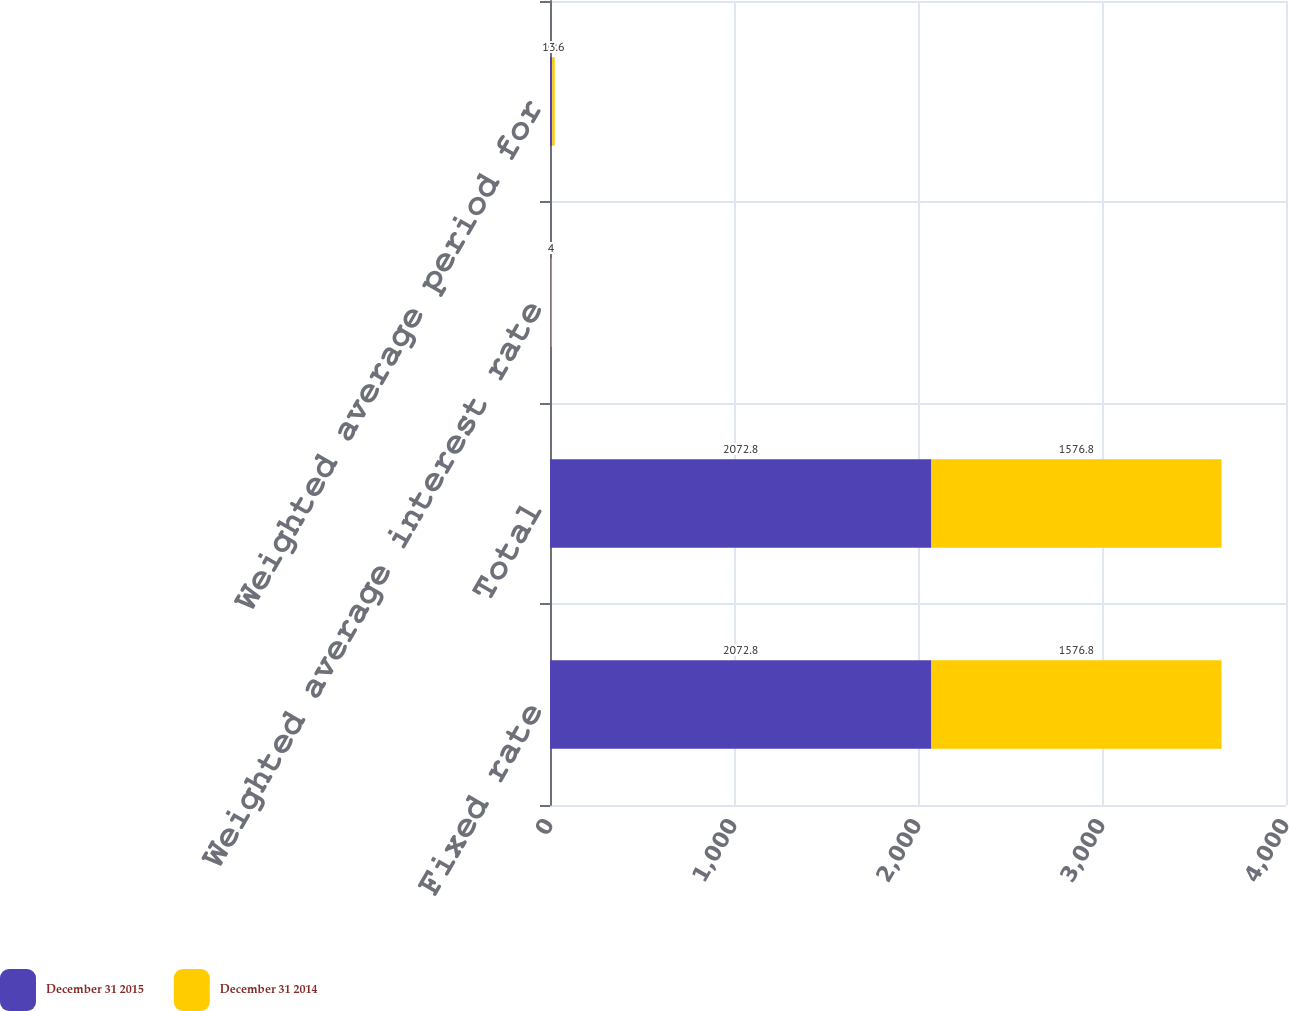Convert chart to OTSL. <chart><loc_0><loc_0><loc_500><loc_500><stacked_bar_chart><ecel><fcel>Fixed rate<fcel>Total<fcel>Weighted average interest rate<fcel>Weighted average period for<nl><fcel>December 31 2015<fcel>2072.8<fcel>2072.8<fcel>4<fcel>12<nl><fcel>December 31 2014<fcel>1576.8<fcel>1576.8<fcel>4<fcel>13.6<nl></chart> 